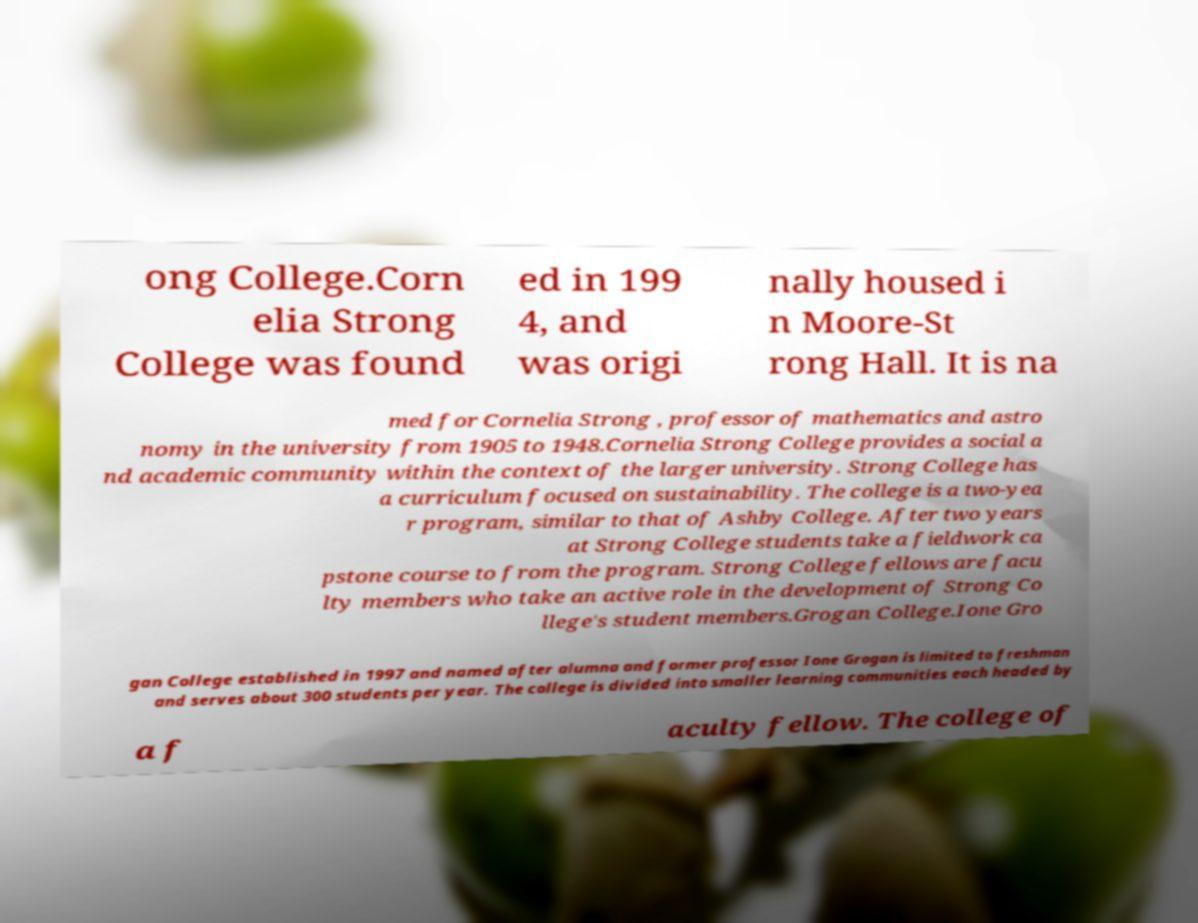What messages or text are displayed in this image? I need them in a readable, typed format. ong College.Corn elia Strong College was found ed in 199 4, and was origi nally housed i n Moore-St rong Hall. It is na med for Cornelia Strong , professor of mathematics and astro nomy in the university from 1905 to 1948.Cornelia Strong College provides a social a nd academic community within the context of the larger university. Strong College has a curriculum focused on sustainability. The college is a two-yea r program, similar to that of Ashby College. After two years at Strong College students take a fieldwork ca pstone course to from the program. Strong College fellows are facu lty members who take an active role in the development of Strong Co llege's student members.Grogan College.Ione Gro gan College established in 1997 and named after alumna and former professor Ione Grogan is limited to freshman and serves about 300 students per year. The college is divided into smaller learning communities each headed by a f aculty fellow. The college of 